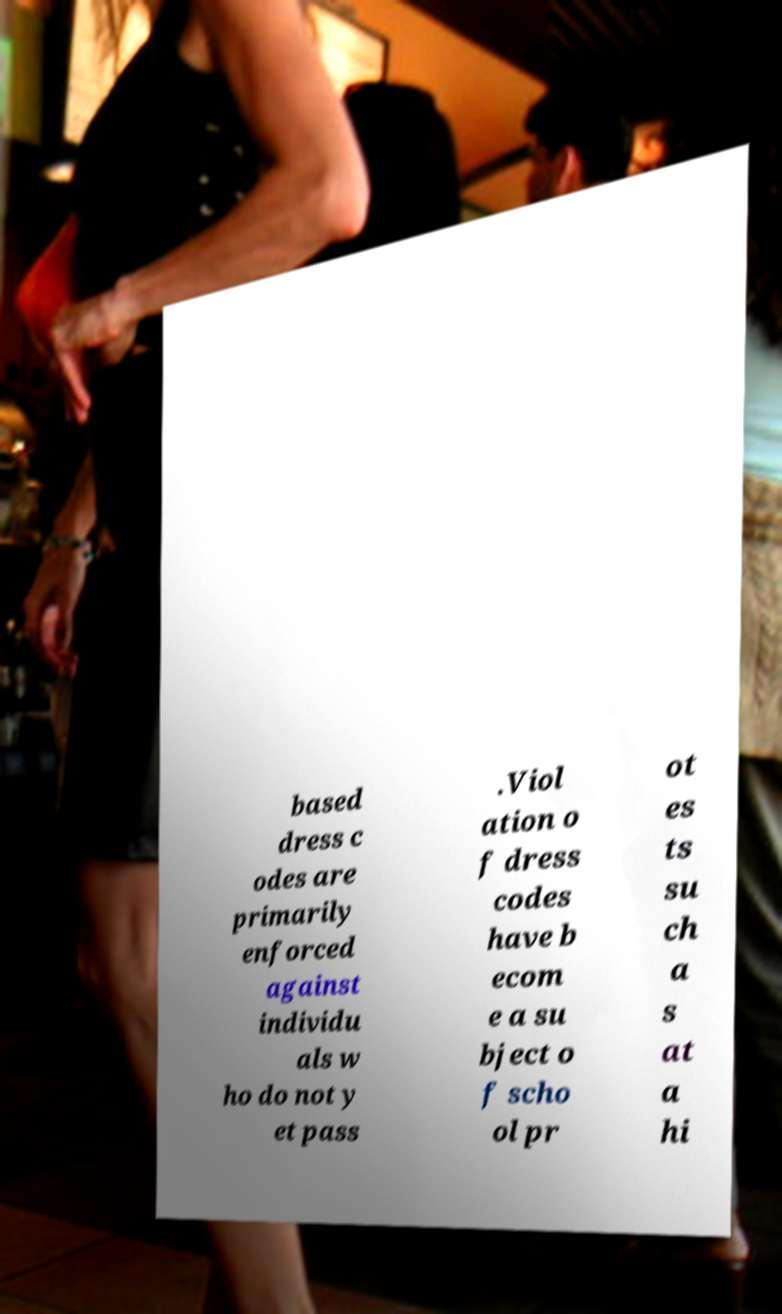Can you accurately transcribe the text from the provided image for me? based dress c odes are primarily enforced against individu als w ho do not y et pass .Viol ation o f dress codes have b ecom e a su bject o f scho ol pr ot es ts su ch a s at a hi 